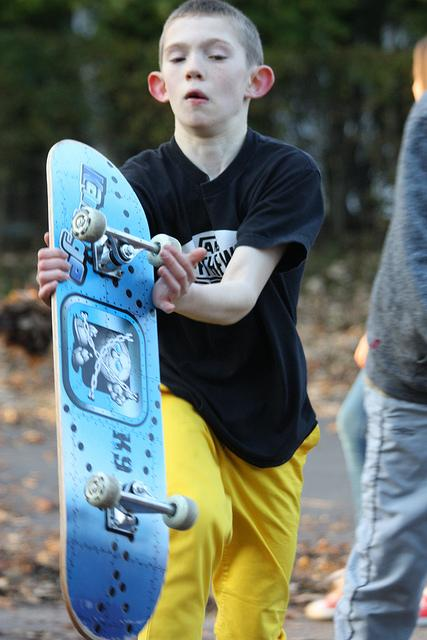What jungle animal do his ears resemble? Please explain your reasoning. monkey. Their ears stick straight out 